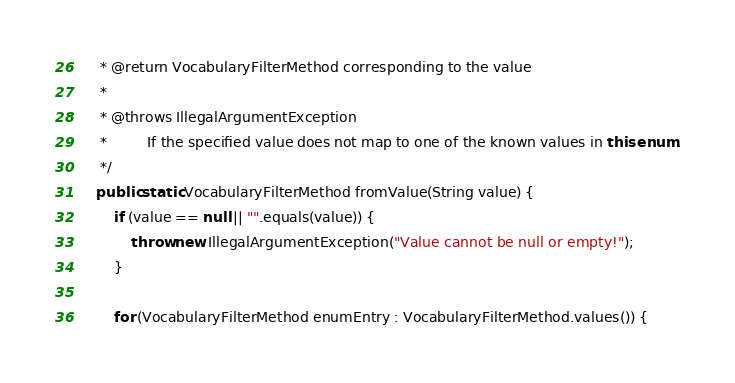<code> <loc_0><loc_0><loc_500><loc_500><_Java_>     * @return VocabularyFilterMethod corresponding to the value
     *
     * @throws IllegalArgumentException
     *         If the specified value does not map to one of the known values in this enum.
     */
    public static VocabularyFilterMethod fromValue(String value) {
        if (value == null || "".equals(value)) {
            throw new IllegalArgumentException("Value cannot be null or empty!");
        }

        for (VocabularyFilterMethod enumEntry : VocabularyFilterMethod.values()) {</code> 